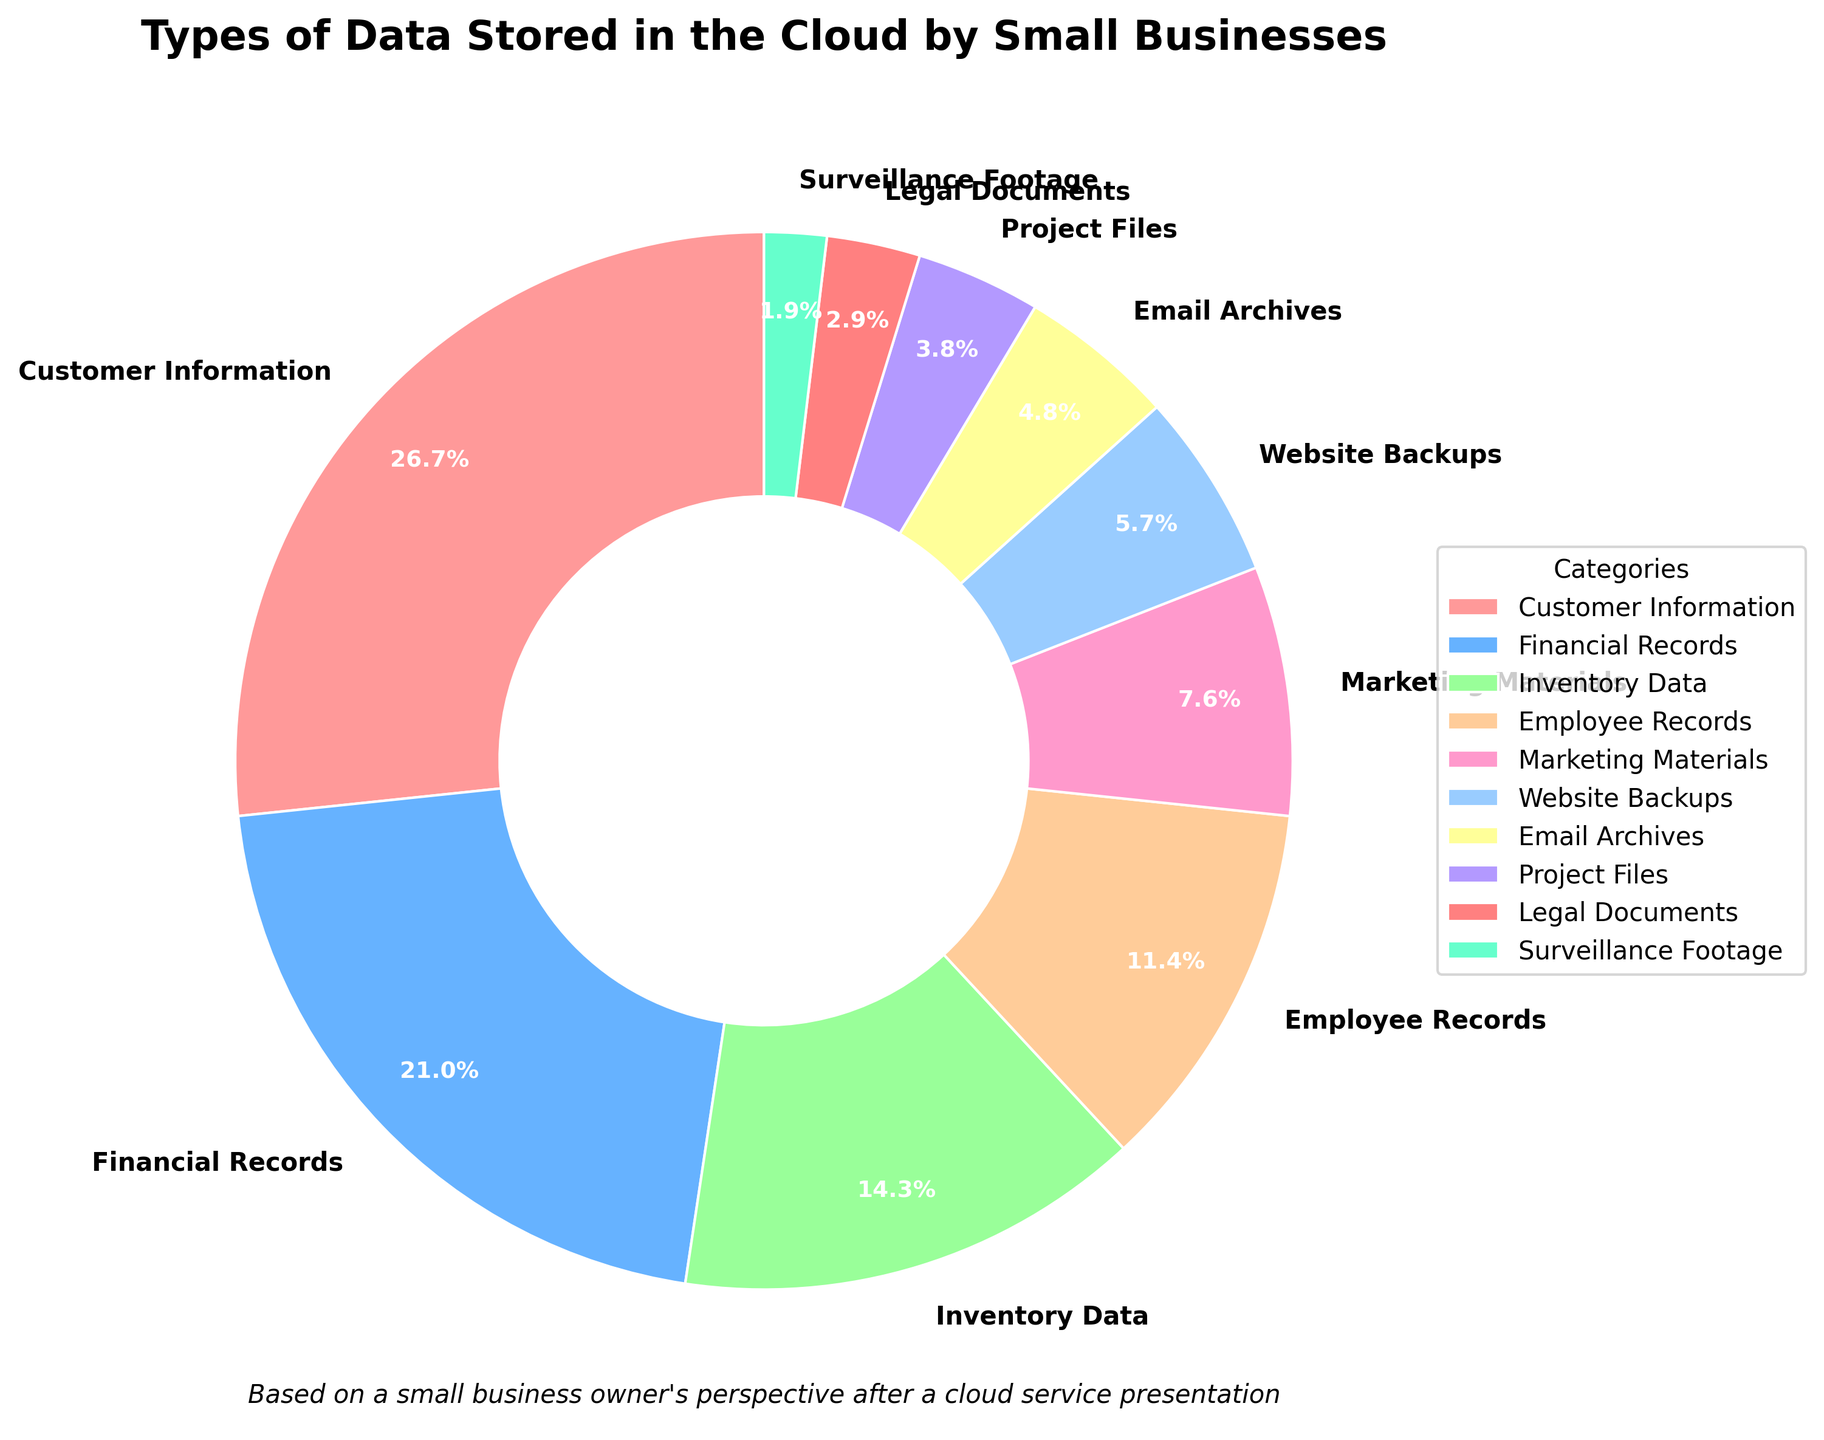What percentage of data categories in the chart make up customer-related information (Customer Information and Email Archives)? Combine the percentages for Customer Information and Email Archives (28 + 5 = 33).
Answer: 33% Which category stores more data: Financial Records or Marketing Materials? Compare their percentages: Financial Records (22%) vs. Marketing Materials (8%). Financial Records has a higher percentage.
Answer: Financial Records How much more data is stored as Inventory Data compared to Project Files? Subtract the percentage of Project Files (4%) from Inventory Data (15%): 15 - 4 = 11.
Answer: 11% Which category contributes the least to the total stored data? Identify the category with the smallest percentage, which is Surveillance Footage at 2%.
Answer: Surveillance Footage Is the percentage of Website Backups greater than that of Email Archives and Project Files combined? Compare Website Backups (6%) to the sum of Email Archives (5%) and Project Files (4%): 6% vs. 5 + 4 = 9%. Website Backups is not greater.
Answer: No Which slices are the largest and smallest in size in the pie chart? The largest slice is Customer Information at 28%, the smallest is Surveillance Footage at 2%.
Answer: Customer Information, Surveillance Footage What type of data is the majority of cloud storage used for by small businesses? The category with the highest percentage is Customer Information at 28%.
Answer: Customer Information How much combined percentage do Employee Records and Marketing Materials make? Add the percentages of Employee Records (12%) and Marketing Materials (8%): 12 + 8 = 20.
Answer: 20% What is the difference in the percentage of data stored between Financial Records and Inventory Data? Subtract the Inventory Data percentage (15%) from Financial Records (22%): 22 - 15 = 7.
Answer: 7% What are the colors used for the categories with the top three highest percentages? Customer Information is red (28%), Financial Records is blue (22%), Inventory Data is green (15%).
Answer: Red, Blue, Green 